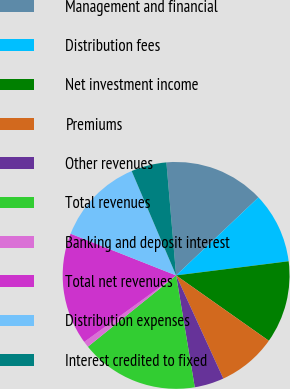Convert chart. <chart><loc_0><loc_0><loc_500><loc_500><pie_chart><fcel>Management and financial<fcel>Distribution fees<fcel>Net investment income<fcel>Premiums<fcel>Other revenues<fcel>Total revenues<fcel>Banking and deposit interest<fcel>Total net revenues<fcel>Distribution expenses<fcel>Interest credited to fixed<nl><fcel>14.29%<fcel>10.08%<fcel>11.76%<fcel>8.4%<fcel>4.2%<fcel>16.81%<fcel>0.84%<fcel>15.97%<fcel>12.6%<fcel>5.04%<nl></chart> 